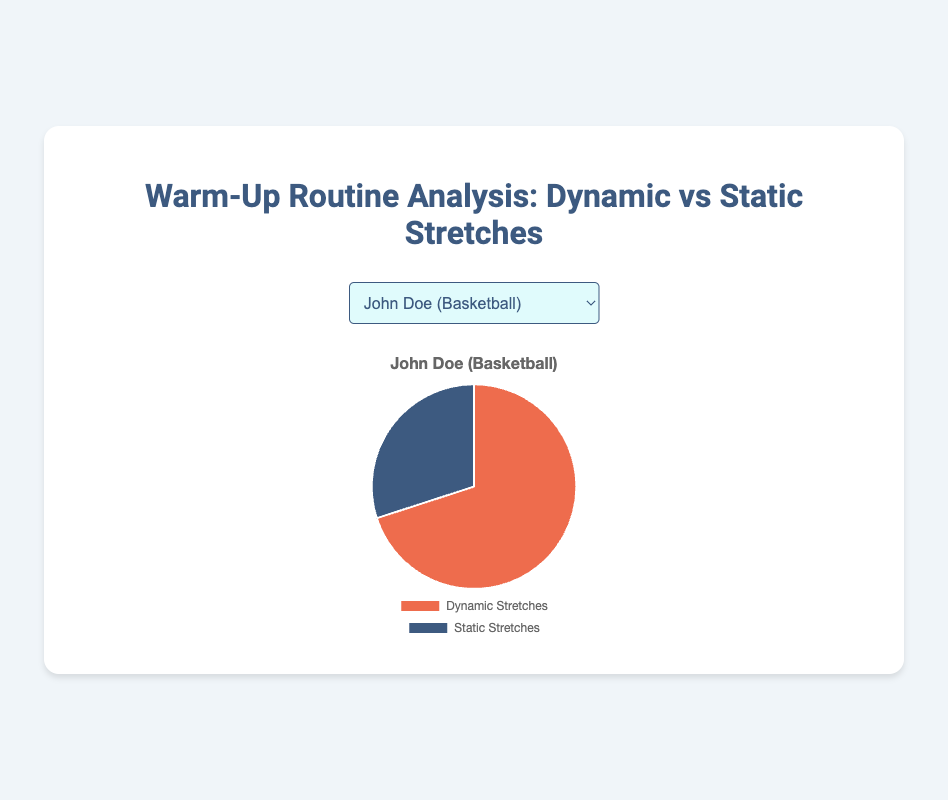What percentage of warm-up time does Emily Davis spend on dynamic stretches? Look at Emily Davis' data and find the percentage for dynamic stretches, which is 80%.
Answer: 80% Who spends more time on static stretches, John Doe or Jane Smith? Compare the static stretches percentage of John Doe (30%) and Jane Smith (35%). Jane Smith spends more time.
Answer: Jane Smith What is the average percentage of dynamic stretches across all athletes? Add up the dynamic stretches percentages (70 + 65 + 60 + 80 + 50) and divide by the number of athletes (5), so (325 / 5) = 65
Answer: 65 Which athlete spends an equal amount of time on dynamic and static stretches? Check the data for percentages of dynamic and static stretches and see that Chris Brown has 50% for both.
Answer: Chris Brown Between Mike Johnson and Emily Davis, who spends the most time on static stretches? Compare Mike Johnson's static stretches percentage (40%) with Emily Davis's (20%), Mike Johnson spends more time.
Answer: Mike Johnson What is the combined percentage of static stretches for John Doe and Jane Smith? Add the static stretches percentages of John Doe (30%) and Jane Smith (35%) (30 + 35), resulting in a combined 65%.
Answer: 65 Who spends the least percentage of their warm-up time on dynamic stretches? Compare the dynamic stretches percentages and find the lowest value, which is Chris Brown at 50%.
Answer: Chris Brown If you average the static stretches percentages of John Doe and Emily Davis, what do you get? Add the static stretches percentages of John Doe (30%) and Emily Davis (20%) and divide by 2, giving (30 + 20) / 2 = 25.
Answer: 25 